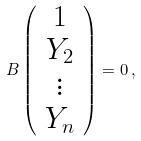<formula> <loc_0><loc_0><loc_500><loc_500>B \left ( \begin{array} { c c } 1 \\ Y _ { 2 } \\ \vdots \\ Y _ { n } \end{array} \right ) = 0 \, ,</formula> 